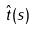Convert formula to latex. <formula><loc_0><loc_0><loc_500><loc_500>\hat { t } ( s )</formula> 